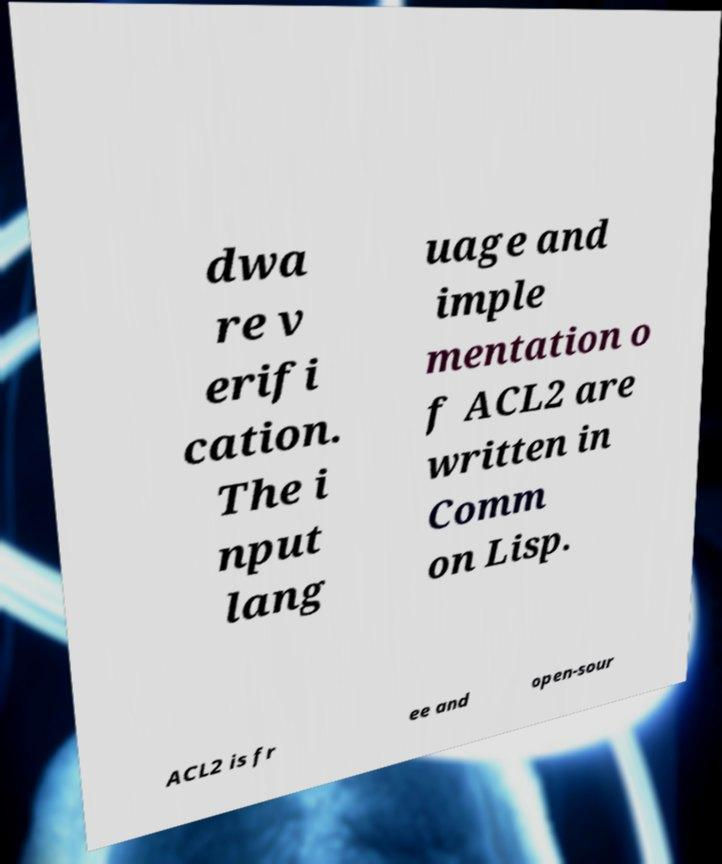Can you read and provide the text displayed in the image?This photo seems to have some interesting text. Can you extract and type it out for me? dwa re v erifi cation. The i nput lang uage and imple mentation o f ACL2 are written in Comm on Lisp. ACL2 is fr ee and open-sour 